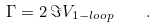<formula> <loc_0><loc_0><loc_500><loc_500>\Gamma = 2 \, \Im V _ { 1 - l o o p } \quad .</formula> 